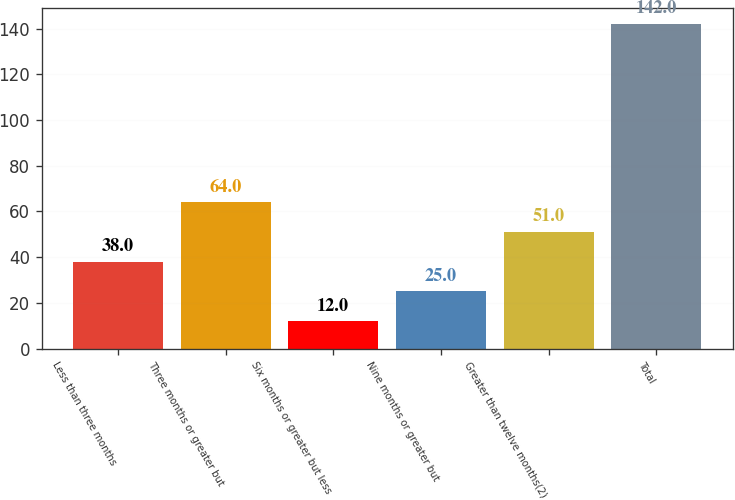<chart> <loc_0><loc_0><loc_500><loc_500><bar_chart><fcel>Less than three months<fcel>Three months or greater but<fcel>Six months or greater but less<fcel>Nine months or greater but<fcel>Greater than twelve months(2)<fcel>Total<nl><fcel>38<fcel>64<fcel>12<fcel>25<fcel>51<fcel>142<nl></chart> 